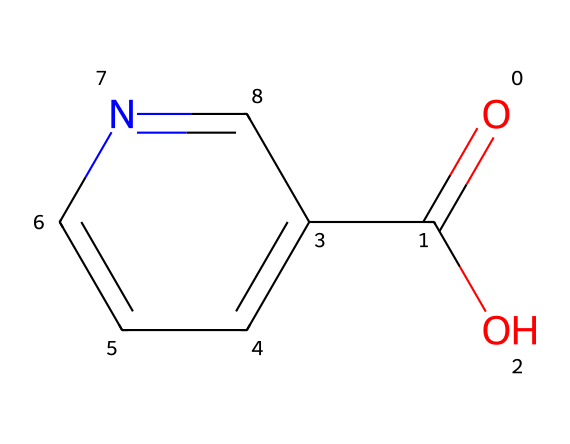What is the chemical name of this compound? The provided SMILES representation corresponds to a compound with the carboxyl group (–COOH) and a pyridine ring, which identifies it as niacin.
Answer: niacin How many carbon atoms are present in the chemical structure? Analyzing the SMILES, we can see there are six carbon atoms; five from the ring and one from the carboxylic acid group.
Answer: six What functional groups are present in this chemical? The structure shows a carboxylic acid group (–COOH) and a pyridine ring, indicating both acidic and aromatic properties.
Answer: carboxylic acid, pyridine How many nitrogen atoms are in the chemical structure? The SMILES indicates that there is one nitrogen atom in the pyridine ring, which is a characteristic of niacin.
Answer: one Is this compound water-soluble? The presence of the carboxylic acid suggests that the compound is polar, leading to its solubility in water.
Answer: yes What type of vitamin is this compound classified as? Based on its structure and biological function, this compound can be classified as a B-vitamin, specifically involved in energy metabolism.
Answer: B-vitamin What role does vitamin B3 play in the body? Vitamin B3 is crucial for energy metabolism, helping in the conversion of carbohydrates, fats, and proteins into energy.
Answer: energy metabolism 